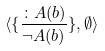Convert formula to latex. <formula><loc_0><loc_0><loc_500><loc_500>\langle \{ \frac { \colon A ( b ) } { \neg A ( b ) } \} , \emptyset \rangle</formula> 